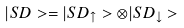<formula> <loc_0><loc_0><loc_500><loc_500>| S D > = | S D _ { \uparrow } > \otimes | S D _ { \downarrow } ></formula> 